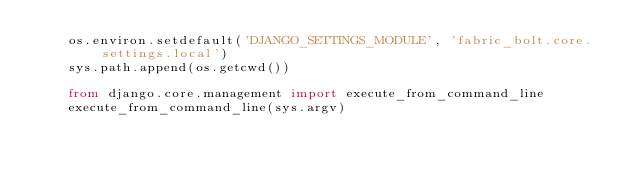<code> <loc_0><loc_0><loc_500><loc_500><_Python_>    os.environ.setdefault('DJANGO_SETTINGS_MODULE', 'fabric_bolt.core.settings.local')
    sys.path.append(os.getcwd())

    from django.core.management import execute_from_command_line
    execute_from_command_line(sys.argv)
</code> 